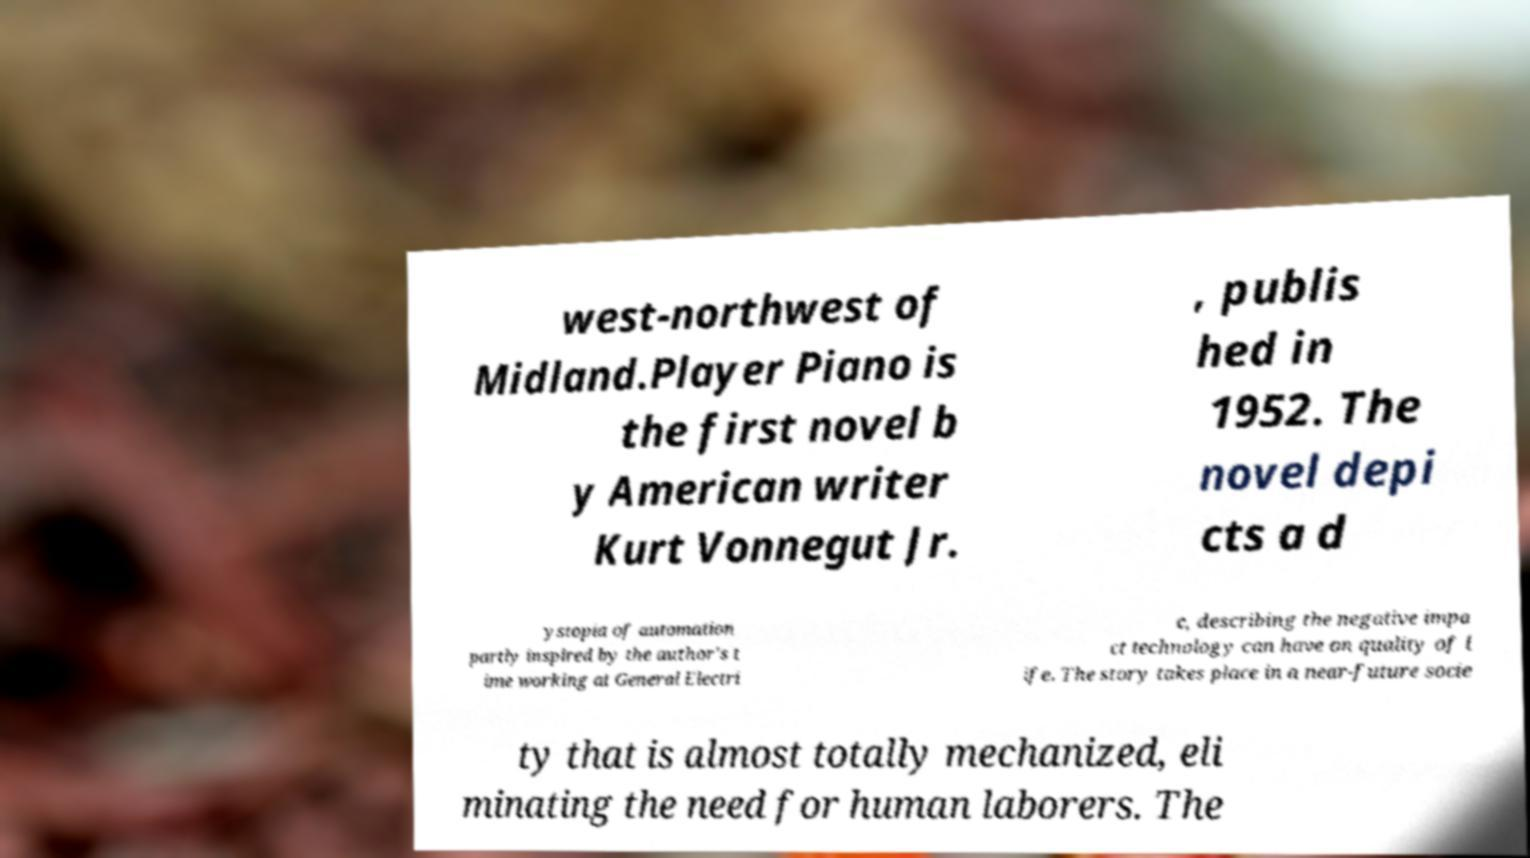Please read and relay the text visible in this image. What does it say? west-northwest of Midland.Player Piano is the first novel b y American writer Kurt Vonnegut Jr. , publis hed in 1952. The novel depi cts a d ystopia of automation partly inspired by the author's t ime working at General Electri c, describing the negative impa ct technology can have on quality of l ife. The story takes place in a near-future socie ty that is almost totally mechanized, eli minating the need for human laborers. The 